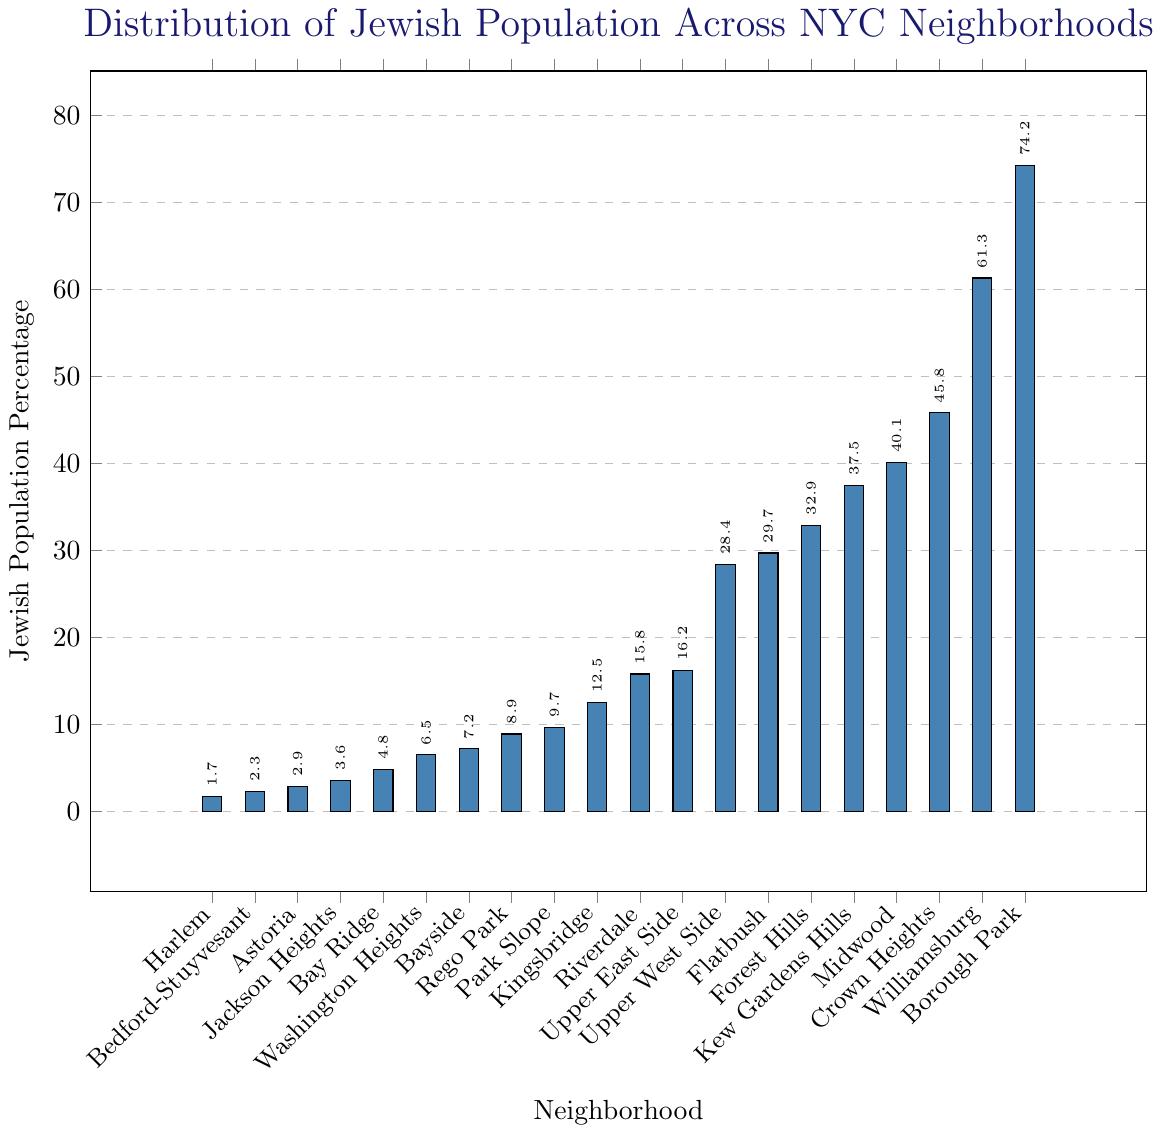What's the neighborhood with the highest Jewish population percentage? Look for the tallest bar in the chart. Borough Park has the highest bar.
Answer: Borough Park What's the neighborhood with the lowest Jewish population percentage? Look for the shortest bar in the chart. Harlem has the shortest bar.
Answer: Harlem What's the difference in Jewish population percentage between Williamsburg and Crown Heights? Identify the bars for Williamsburg and Crown Heights and subtract the percentage of Crown Heights from Williamsburg (61.3 - 45.8).
Answer: 15.5 Which neighborhoods have a Jewish population percentage above 50%? Look at the bars and identify those above 50%. The bars for Borough Park and Williamsburg are above 50%.
Answer: Borough Park, Williamsburg What's the average Jewish population percentage of the top three neighborhoods with the highest percentage? Find the top three neighborhoods (Borough Park, Williamsburg, Crown Heights), then average their percentages ((74.2 + 61.3 + 45.8)/3).
Answer: 60.433 How many neighborhoods have a Jewish population percentage under 10%? Count all bars that are below the 10% mark.
Answer: 8 Which neighborhood has a Jewish population percentage closest to 30%? Look for the bar closest to the 30% mark. Flatbush has a bar closest to 30% (29.7).
Answer: Flatbush Compare the Jewish population percentage of Upper West Side and Upper East Side. Which one is higher, and by how much? Find the bars for Upper West Side and Upper East Side, and compare the heights. The Upper West Side is higher than the Upper East Side by 28.4 - 16.2 = 12.2.
Answer: Upper West Side, 12.2 What's the total Jewish population percentage of Flatbush, Forest Hills, and Kew Gardens Hills combined? Sum the percentages of these three neighborhoods (29.7 + 32.9 + 37.5).
Answer: 100.1 What's the median Jewish population percentage of all the neighborhoods? First, list all the percentages in ascending order, find the middle value, or average the two middle values if the list has an even number of entries.
Answer: 16.2 